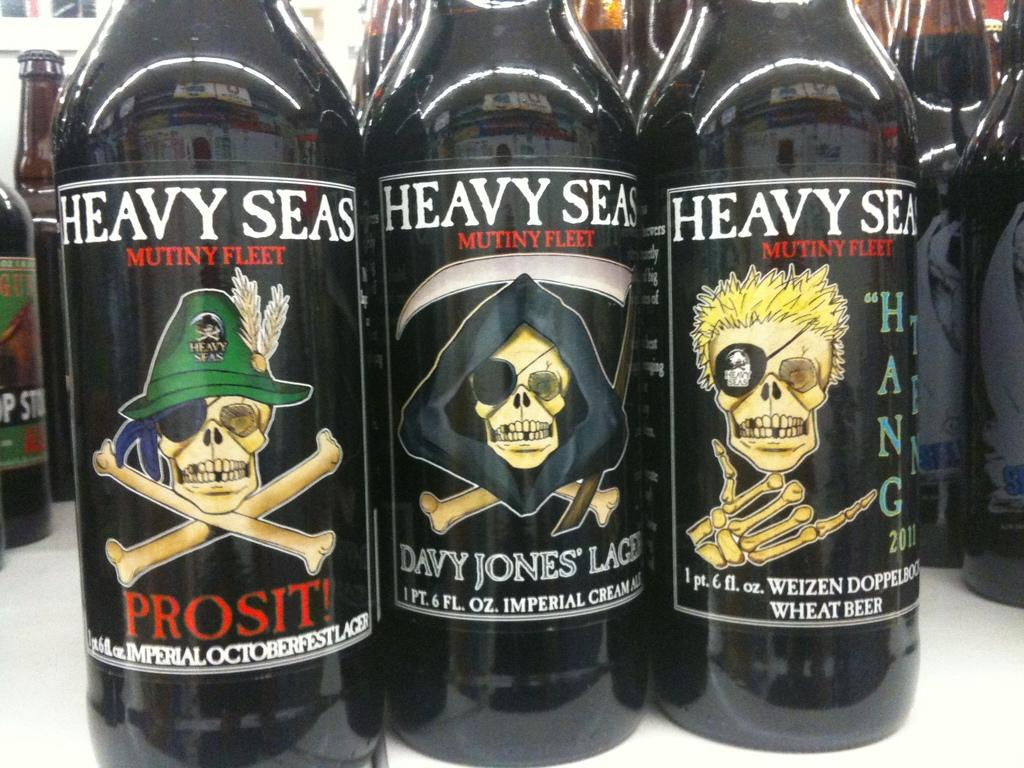<image>
Summarize the visual content of the image. Three different kinds of heavy Seas lager each showing a different character are displayed close up on the table. 